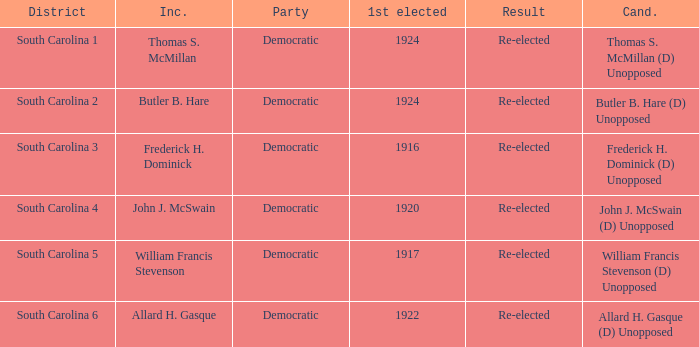Would you mind parsing the complete table? {'header': ['District', 'Inc.', 'Party', '1st elected', 'Result', 'Cand.'], 'rows': [['South Carolina 1', 'Thomas S. McMillan', 'Democratic', '1924', 'Re-elected', 'Thomas S. McMillan (D) Unopposed'], ['South Carolina 2', 'Butler B. Hare', 'Democratic', '1924', 'Re-elected', 'Butler B. Hare (D) Unopposed'], ['South Carolina 3', 'Frederick H. Dominick', 'Democratic', '1916', 'Re-elected', 'Frederick H. Dominick (D) Unopposed'], ['South Carolina 4', 'John J. McSwain', 'Democratic', '1920', 'Re-elected', 'John J. McSwain (D) Unopposed'], ['South Carolina 5', 'William Francis Stevenson', 'Democratic', '1917', 'Re-elected', 'William Francis Stevenson (D) Unopposed'], ['South Carolina 6', 'Allard H. Gasque', 'Democratic', '1922', 'Re-elected', 'Allard H. Gasque (D) Unopposed']]} What is the result for south carolina 4? Re-elected. 